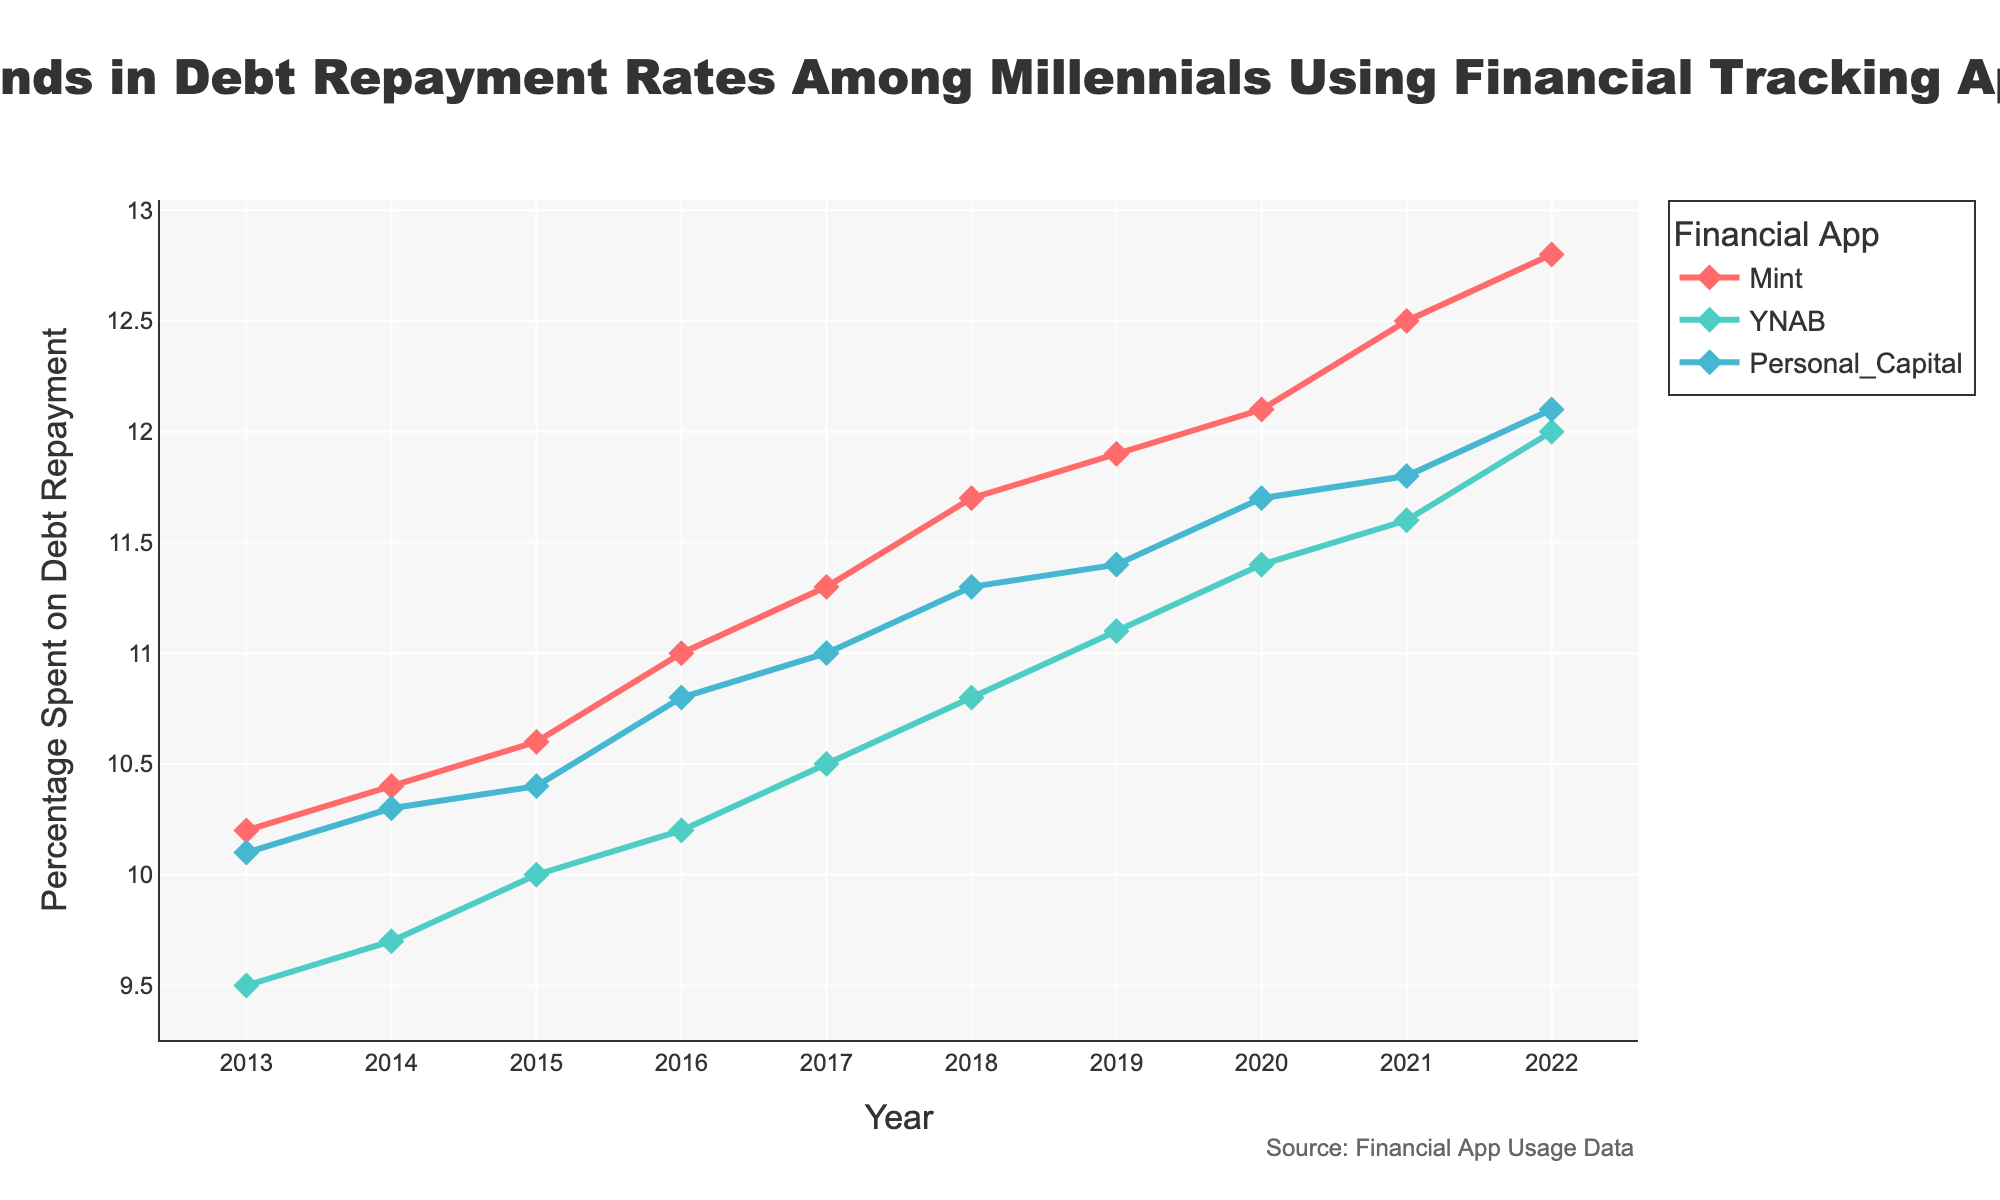what is the title of the figure? The title is usually located at the top of the figure, highlighted prominently to describe what the figure represents. In this case, the title is "Trends in Debt Repayment Rates Among Millennials Using Financial Tracking Apps."
Answer: Trends in Debt Repayment Rates Among Millennials Using Financial Tracking Apps how many financial tracking apps are included in the analysis? By examining the legend in the figure, we can see three financial tracking apps: Mint, YNAB, and Personal Capital.
Answer: 3 what is the overall trend in debt repayment rates for Mint users over the last decade? Observing the line representing Mint in the figure, we can see a consistent upward trend in the percentage spent on debt repayment from 2013 to 2022.
Answer: Increasing which year shows the highest debt repayment rate among Personal Capital users? By comparing the data points for Personal Capital, the highest percentage spent on debt repayment occurs in 2022.
Answer: 2022 compare the debt repayment rates of ynab and mint users in 2020. which app had higher rates? In 2020, looking at the points for YNAB and Mint, Mint users had a higher debt repayment rate with roughly 12.1%, while YNAB users had around 11.4%.
Answer: Mint which app had the lowest initial debt repayment rate in 2013? By checking the data points for 2013, YNAB had the lowest debt repayment rate at approximately 9.5%.
Answer: YNAB what is the average debt repayment rate for Personal Capital users from 2013 to 2022? Adding up the data points for each year from 2013 to 2022 for Personal Capital (10.1, 10.3, 10.4, 10.8, 11.0, 11.3, 11.4, 11.7, 11.8, 12.1) gives a total of 111.9. Dividing by the 10 years, the average is 11.19%.
Answer: 11.19% how does the debt repayment rate for ynab users in 2017 compare to 2022? YNAB users had a rate of about 10.5% in 2017 compared to around 12% in 2022, showing an increase over the years.
Answer: Increased which year shows the smallest difference in debt repayment rates between Mint and YNAB users? By examining the data over the years and calculating the differences, the smallest difference occurs in 2013, where Mint had 10.2% and YNAB had 9.5%, a difference of 0.7 percentage points.
Answer: 2013 what is the trend in debt repayment rates among millennials using financial tracking apps over the last decade? Analyzing the general direction of the lines representing all three apps, we see an overall increasing trend in debt repayment rates from 2013 to 2022.
Answer: Increasing 